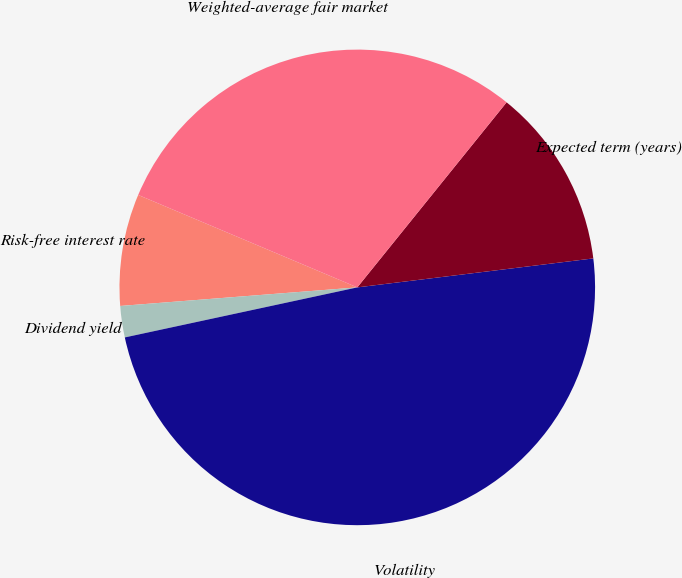Convert chart to OTSL. <chart><loc_0><loc_0><loc_500><loc_500><pie_chart><fcel>Risk-free interest rate<fcel>Dividend yield<fcel>Volatility<fcel>Expected term (years)<fcel>Weighted-average fair market<nl><fcel>7.6%<fcel>2.13%<fcel>48.57%<fcel>12.25%<fcel>29.45%<nl></chart> 